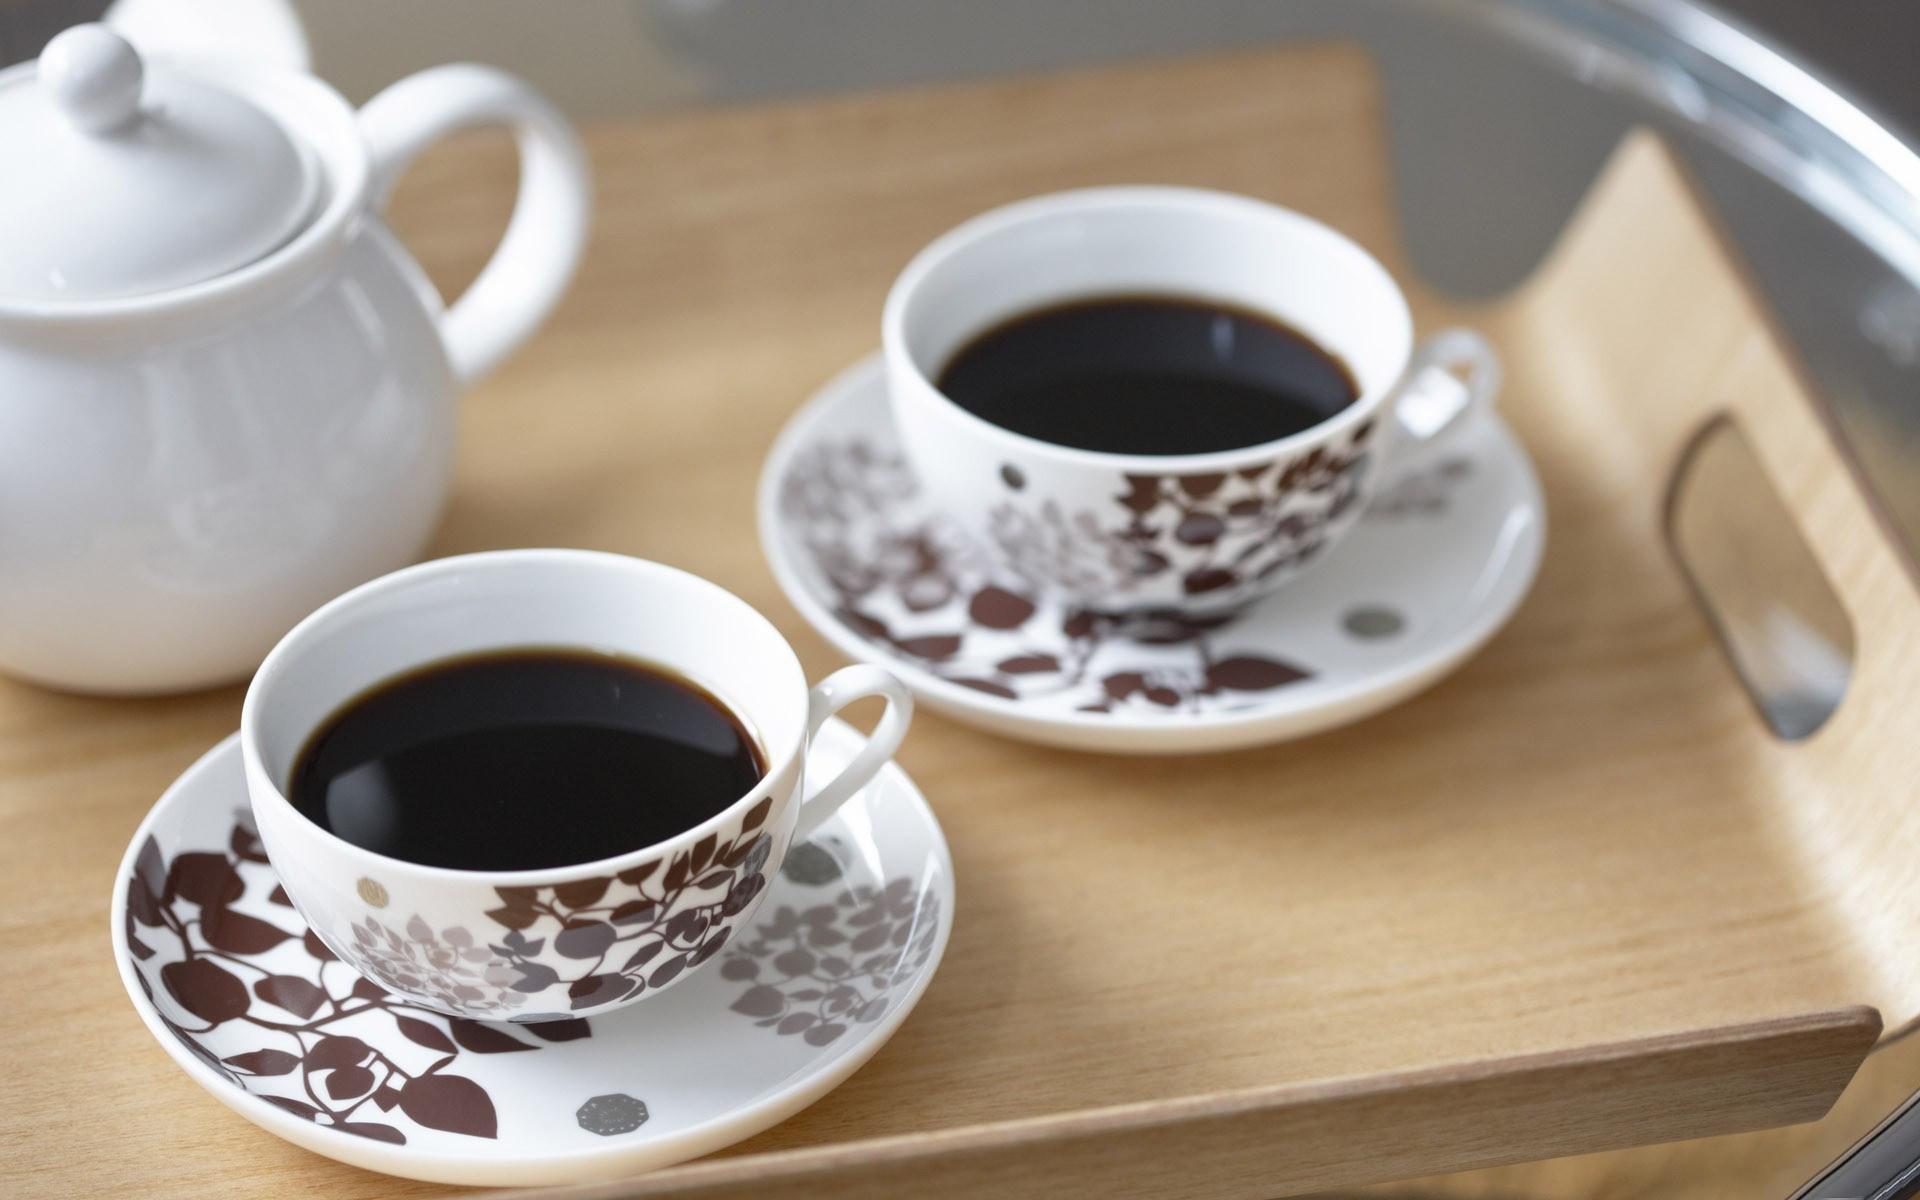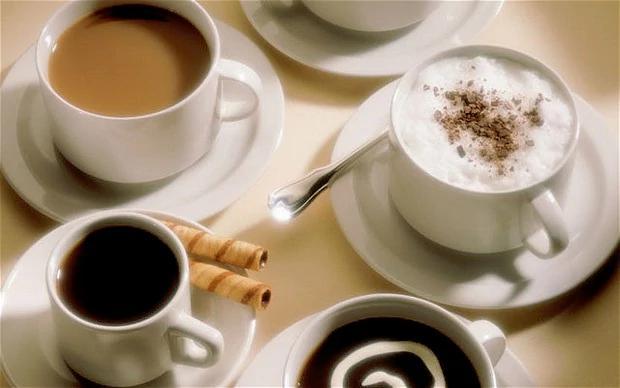The first image is the image on the left, the second image is the image on the right. Considering the images on both sides, is "There are no more than two cups of coffee in the right image." valid? Answer yes or no. No. 